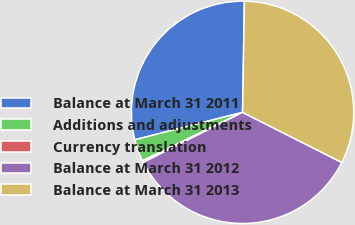Convert chart. <chart><loc_0><loc_0><loc_500><loc_500><pie_chart><fcel>Balance at March 31 2011<fcel>Additions and adjustments<fcel>Currency translation<fcel>Balance at March 31 2012<fcel>Balance at March 31 2013<nl><fcel>29.24%<fcel>3.2%<fcel>0.26%<fcel>35.12%<fcel>32.18%<nl></chart> 